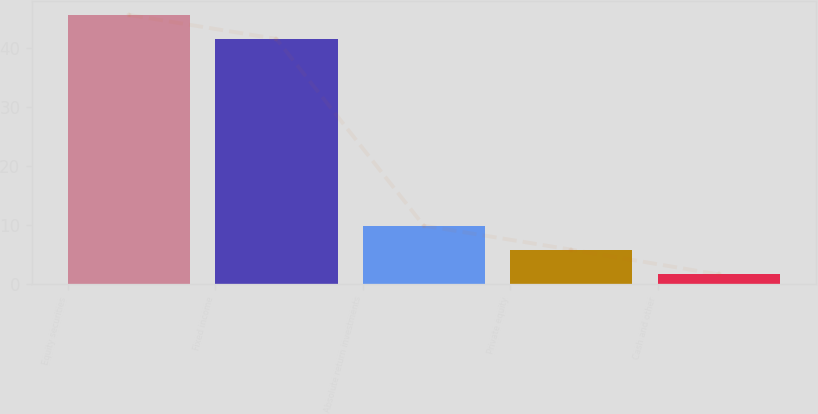Convert chart to OTSL. <chart><loc_0><loc_0><loc_500><loc_500><bar_chart><fcel>Equity securities<fcel>Fixed income<fcel>Absolute return investments<fcel>Private equity<fcel>Cash and other<nl><fcel>45.56<fcel>41.5<fcel>9.86<fcel>5.8<fcel>1.6<nl></chart> 